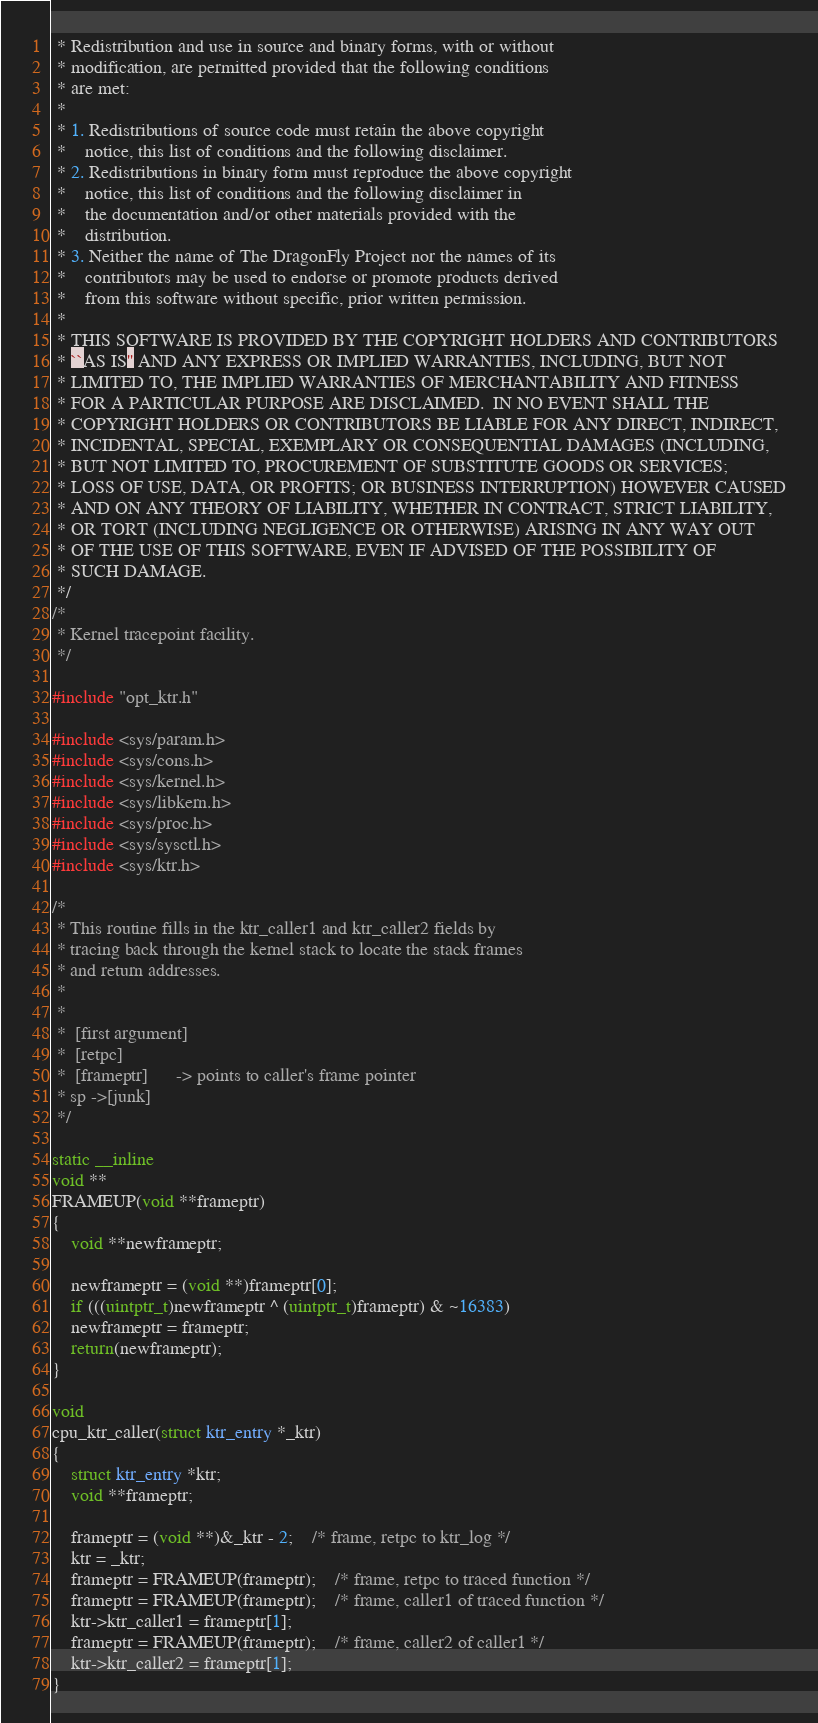<code> <loc_0><loc_0><loc_500><loc_500><_C_> * Redistribution and use in source and binary forms, with or without
 * modification, are permitted provided that the following conditions
 * are met:
 *
 * 1. Redistributions of source code must retain the above copyright
 *    notice, this list of conditions and the following disclaimer.
 * 2. Redistributions in binary form must reproduce the above copyright
 *    notice, this list of conditions and the following disclaimer in
 *    the documentation and/or other materials provided with the
 *    distribution.
 * 3. Neither the name of The DragonFly Project nor the names of its
 *    contributors may be used to endorse or promote products derived
 *    from this software without specific, prior written permission.
 *
 * THIS SOFTWARE IS PROVIDED BY THE COPYRIGHT HOLDERS AND CONTRIBUTORS
 * ``AS IS'' AND ANY EXPRESS OR IMPLIED WARRANTIES, INCLUDING, BUT NOT
 * LIMITED TO, THE IMPLIED WARRANTIES OF MERCHANTABILITY AND FITNESS
 * FOR A PARTICULAR PURPOSE ARE DISCLAIMED.  IN NO EVENT SHALL THE
 * COPYRIGHT HOLDERS OR CONTRIBUTORS BE LIABLE FOR ANY DIRECT, INDIRECT,
 * INCIDENTAL, SPECIAL, EXEMPLARY OR CONSEQUENTIAL DAMAGES (INCLUDING,
 * BUT NOT LIMITED TO, PROCUREMENT OF SUBSTITUTE GOODS OR SERVICES;
 * LOSS OF USE, DATA, OR PROFITS; OR BUSINESS INTERRUPTION) HOWEVER CAUSED
 * AND ON ANY THEORY OF LIABILITY, WHETHER IN CONTRACT, STRICT LIABILITY,
 * OR TORT (INCLUDING NEGLIGENCE OR OTHERWISE) ARISING IN ANY WAY OUT
 * OF THE USE OF THIS SOFTWARE, EVEN IF ADVISED OF THE POSSIBILITY OF
 * SUCH DAMAGE.
 */
/*
 * Kernel tracepoint facility.
 */

#include "opt_ktr.h"

#include <sys/param.h>
#include <sys/cons.h>
#include <sys/kernel.h>
#include <sys/libkern.h>
#include <sys/proc.h>
#include <sys/sysctl.h>
#include <sys/ktr.h>

/*
 * This routine fills in the ktr_caller1 and ktr_caller2 fields by
 * tracing back through the kernel stack to locate the stack frames
 * and return addresses.
 *
 *
 *	[first argument]
 *	[retpc]
 *	[frameptr]		-> points to caller's frame pointer
 * sp ->[junk]
 */

static __inline
void **
FRAMEUP(void **frameptr)
{
    void **newframeptr;

    newframeptr = (void **)frameptr[0];
    if (((uintptr_t)newframeptr ^ (uintptr_t)frameptr) & ~16383)
	newframeptr = frameptr;
    return(newframeptr);
}

void
cpu_ktr_caller(struct ktr_entry *_ktr)
{
    struct ktr_entry *ktr;
    void **frameptr;

    frameptr = (void **)&_ktr - 2;	/* frame, retpc to ktr_log */
    ktr = _ktr;
    frameptr = FRAMEUP(frameptr);	/* frame, retpc to traced function */
    frameptr = FRAMEUP(frameptr);	/* frame, caller1 of traced function */
    ktr->ktr_caller1 = frameptr[1];
    frameptr = FRAMEUP(frameptr);	/* frame, caller2 of caller1 */
    ktr->ktr_caller2 = frameptr[1];
}
</code> 